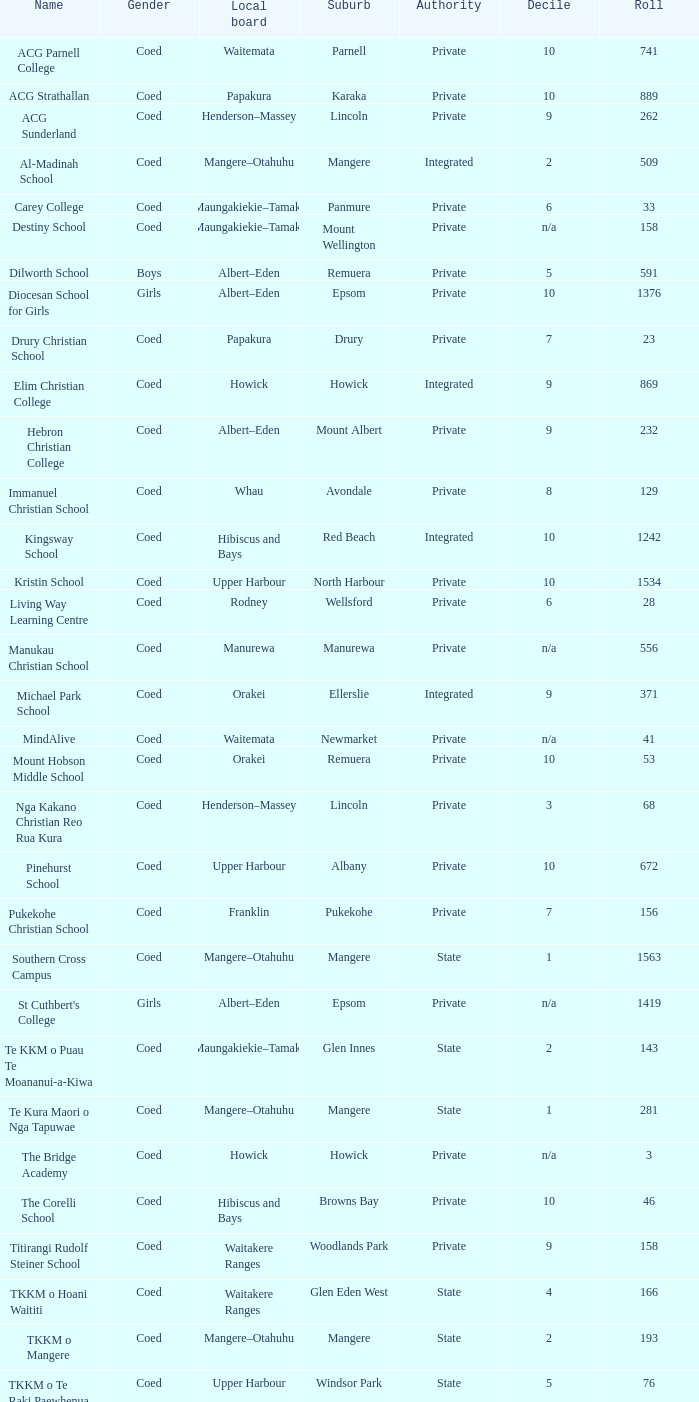What designation appears as private jurisdiction and hibiscus and bays local board? The Corelli School. 